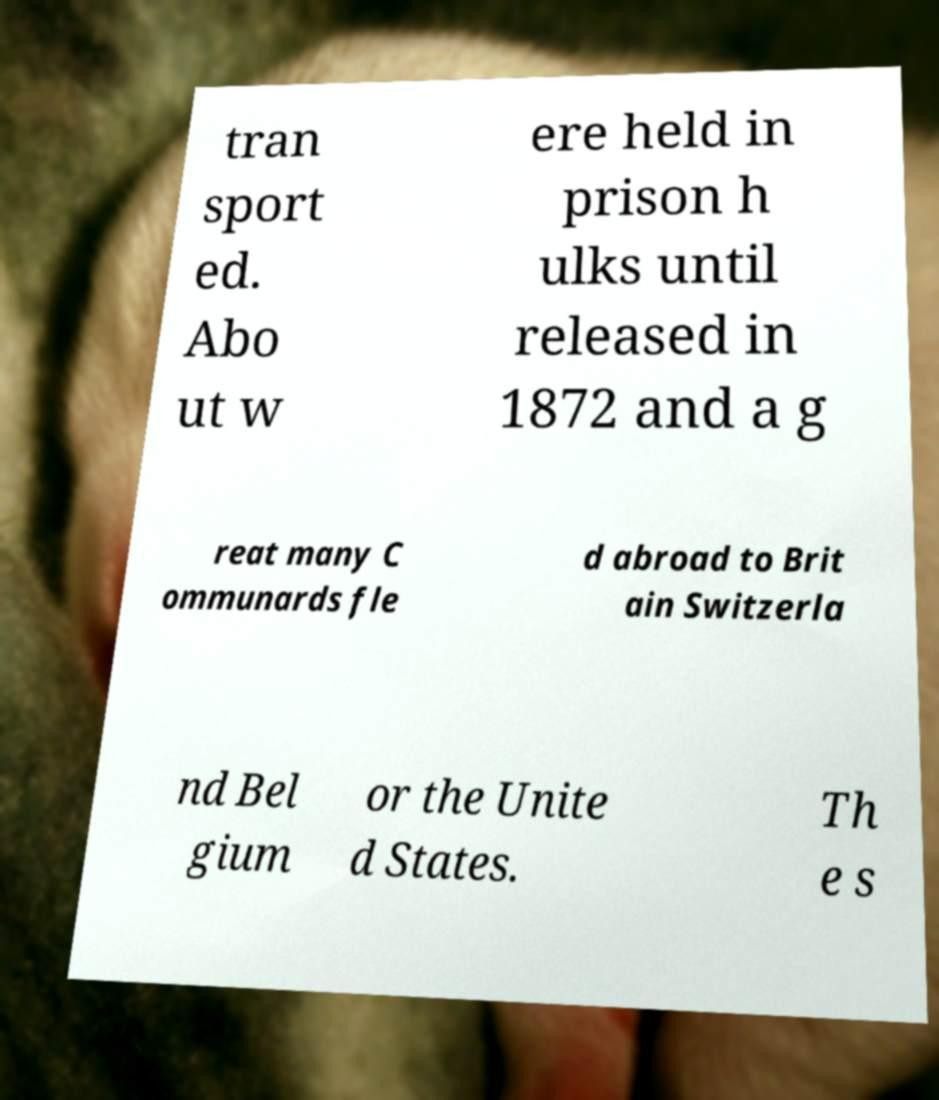Please read and relay the text visible in this image. What does it say? tran sport ed. Abo ut w ere held in prison h ulks until released in 1872 and a g reat many C ommunards fle d abroad to Brit ain Switzerla nd Bel gium or the Unite d States. Th e s 